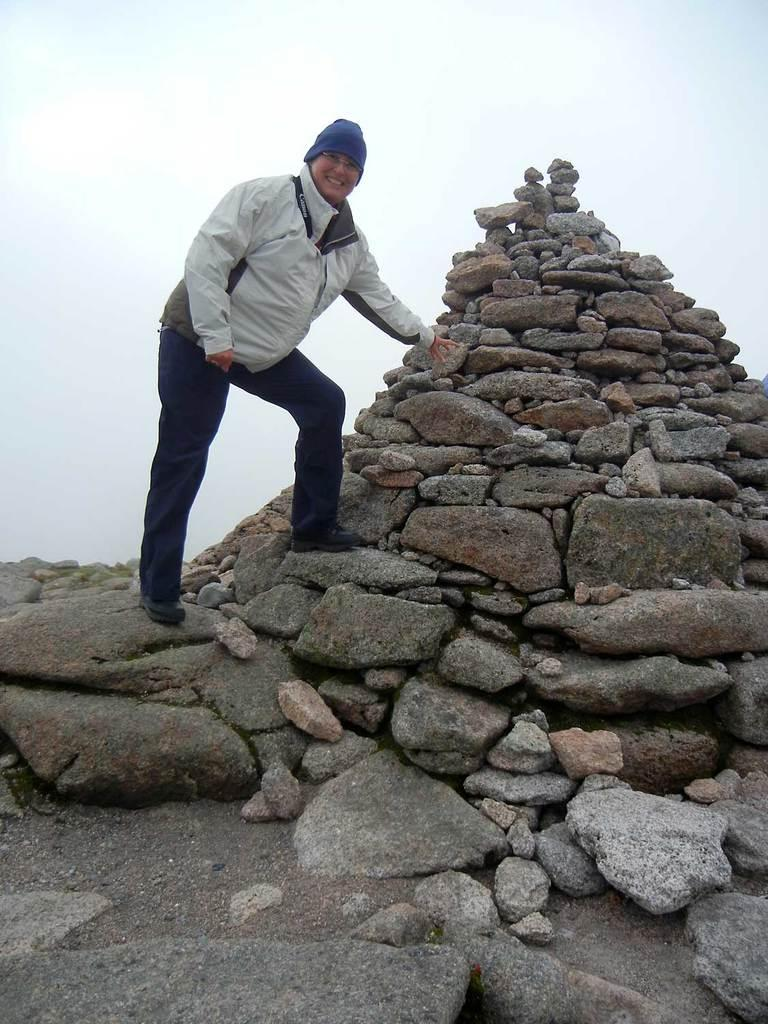What is located in the center of the image? There are stones in the center of the image. Can you describe the person in the image? There is a person standing in the image. What expression does the person have? The person is smiling. What is the price of the yam being held by the person in the image? There is no yam present in the image, and therefore no price can be determined. 